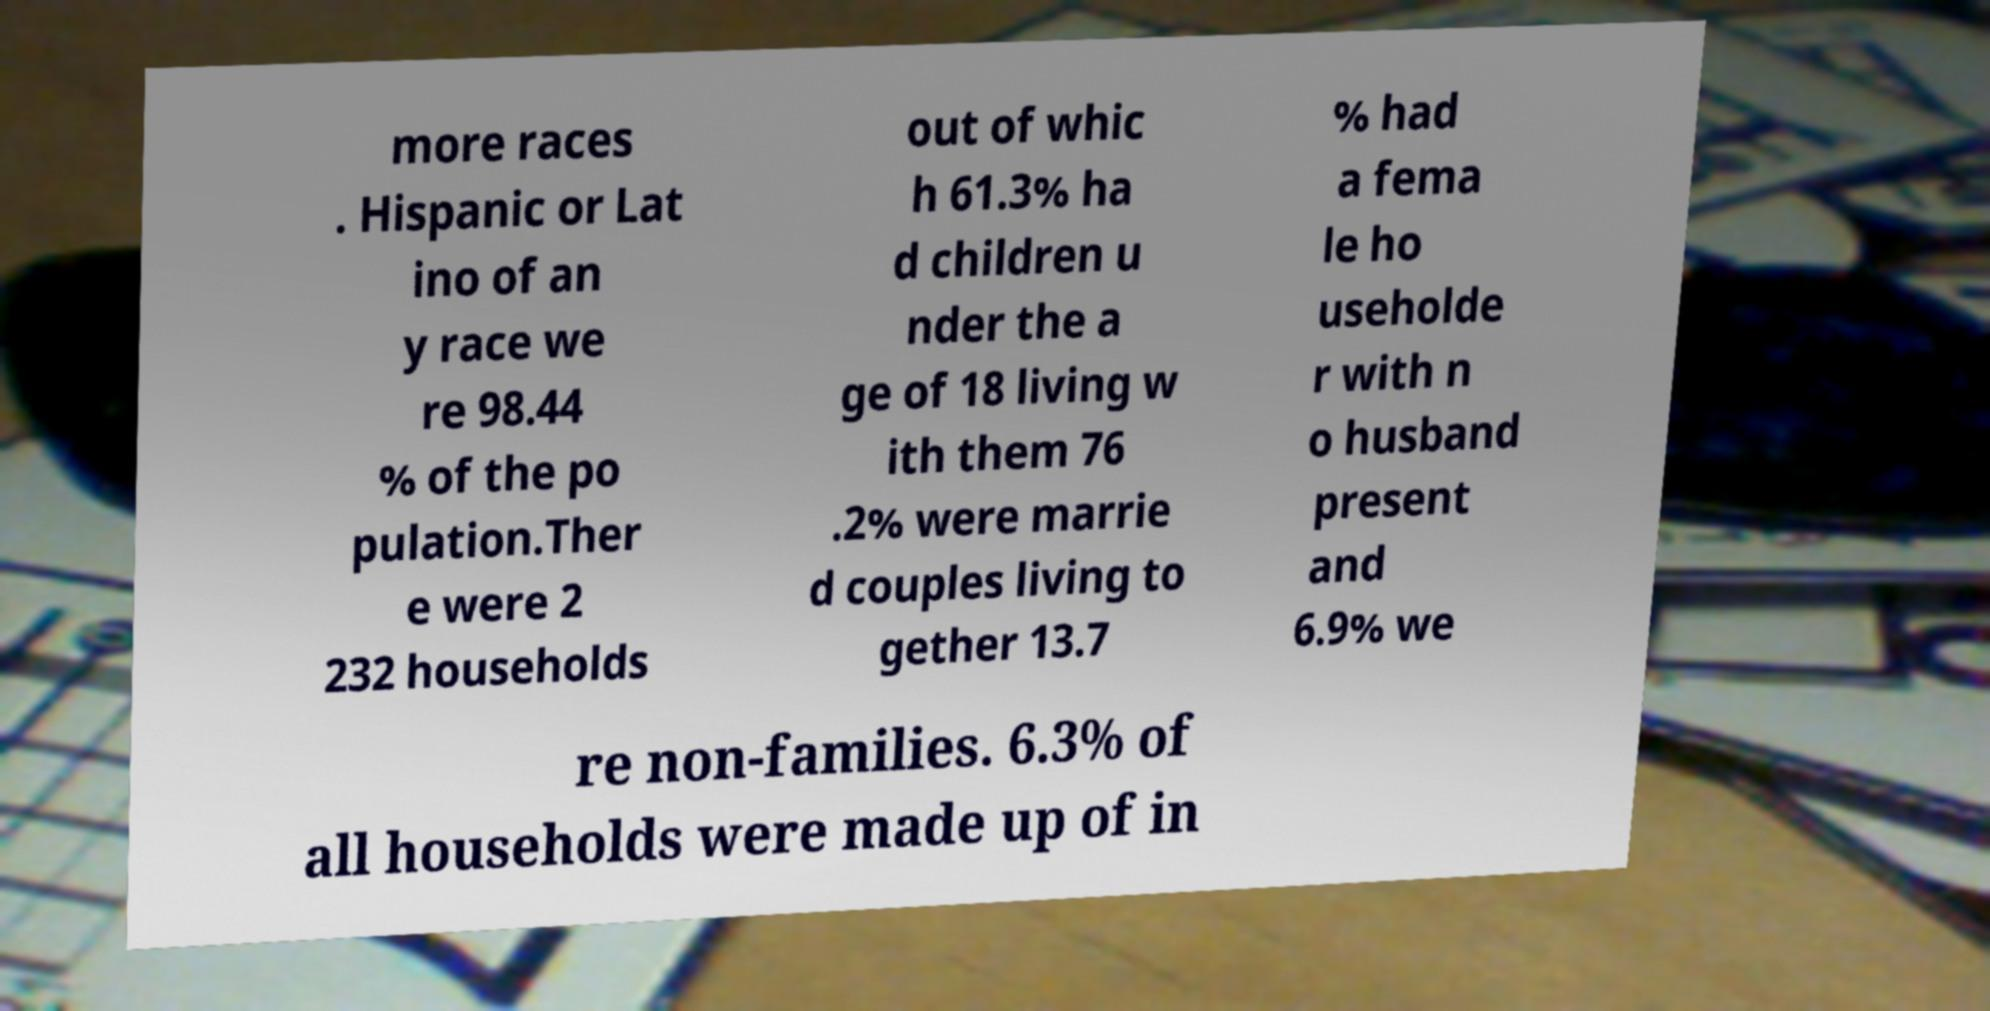Please read and relay the text visible in this image. What does it say? more races . Hispanic or Lat ino of an y race we re 98.44 % of the po pulation.Ther e were 2 232 households out of whic h 61.3% ha d children u nder the a ge of 18 living w ith them 76 .2% were marrie d couples living to gether 13.7 % had a fema le ho useholde r with n o husband present and 6.9% we re non-families. 6.3% of all households were made up of in 